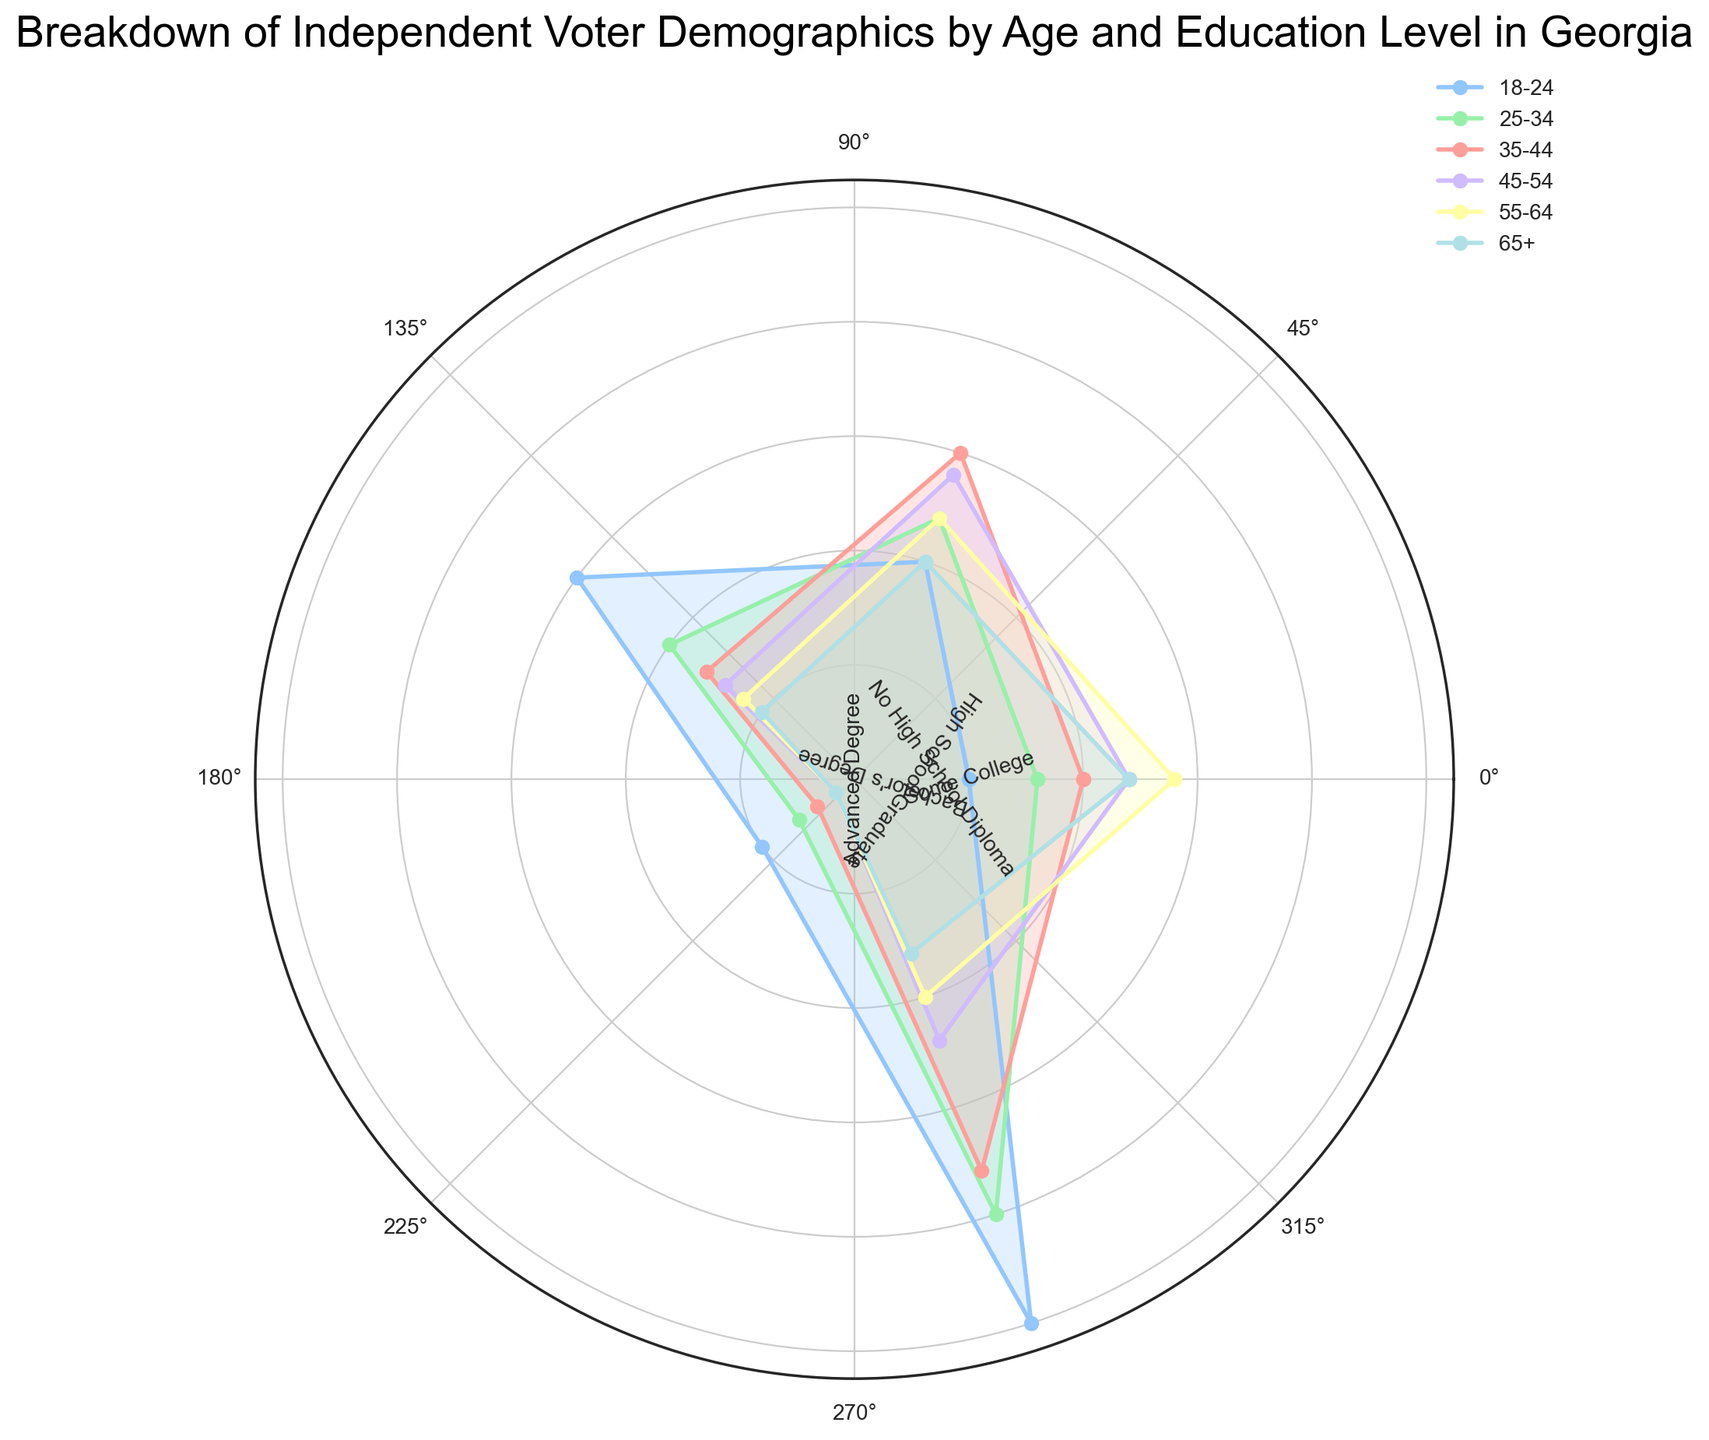What's the largest percentage for some college across all age ranges? To find the largest percentage for 'Some College' across all age ranges, scan the rose chart for the 'Some College' segment in each age range. The ages and their respective percentages are: 18-24 (25%), 25-34 (20%), 35-44 (18%), 45-54 (12%), 55-64 (10%), and 65+ (8%). The highest percentage is 25% for the 18-24 age range.
Answer: 25% Which age group has the highest percentage of high school graduates? To determine which age group has the highest percentage of 'High School Graduate', check the length of the 'High School Graduate' segment for each age range in the rose chart. The highest percentage is found in the 18-24 age range with 15%.
Answer: 18-24 For advanced degrees, which age range has the highest percentage and how much greater is it compared to the lowest? Check the 'Advanced Degree' segment for each age range in the rose chart. The percentages are: 18-24 (5%), 25-34 (8%), 35-44 (10%), 45-54 (12%), 55-64 (14%), and 65+ (12%). The highest percentage is for age range 55-64 at 14%. The lowest percentage is for age range 18-24 at 5%. The difference is 14% - 5% = 9%.
Answer: 55-64, 9% What's the average percentage of no high school diploma across all age ranges? To calculate the average percentage for 'No High School Diploma', sum the percentages for each age range: 18-24 (5%), 25-34 (3%), 35-44 (2%), 45-54 (1%), 55-64 (1%), and 65+ (1%). Sum = 5 + 3 + 2 + 1 + 1 + 1 = 13. There are 6 age ranges, so the average is 13/6 ≈ 2.17%.
Answer: 2.17% Is the percentage of bachelor's degrees for the 35-44 age range greater than for the 55-64 age range? From the rose chart, check the percentage for 'Bachelor's Degree' in both 35-44 and 55-64 age ranges. 35-44 has 15% and 55-64 has 12%. 15% is greater than 12%.
Answer: Yes Compare the percentage of advanced degrees between the 25-34 and 45-54 age ranges. From the rose chart, check the percentages for 'Advanced Degree' for 25-34 and 45-54 age ranges. 25-34 has 8% and 45-54 has 12%. 12% is greater than 8%.
Answer: 45-54 > 25-34 Which age range has the smallest variance in education level distribution? To find the age range with the smallest variance in education levels, visually inspect which age range has the most balanced segment lengths for all education levels. The 65+ age range has the most balanced distribution with percentages closer together compared to other age ranges.
Answer: 65+ How does the percentage of some college for the 35-44 age range compare to advanced degrees for the same age range? Check the rose chart segments for 'Some College' and 'Advanced Degree' in the 35-44 age range. 'Some College' is 18%, and 'Advanced Degree' is 10%. 18% is greater than 10%.
Answer: Greater What is the difference in percentage of high school graduates between the oldest and youngest age ranges? From the rose chart, the percentage of 'High School Graduate' for the 65+ age range is 5%, and for the 18-24 age range is 15%. The difference is 15% - 5% = 10%.
Answer: 10% 